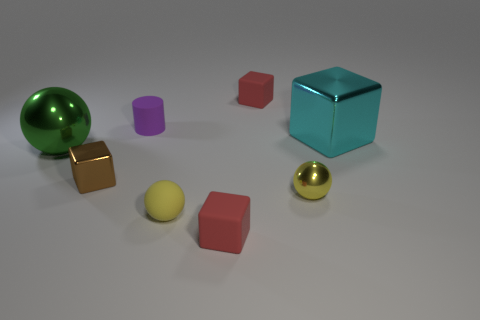Subtract all small yellow shiny balls. How many balls are left? 2 Add 2 shiny balls. How many objects exist? 10 Subtract all green balls. How many balls are left? 2 Subtract all green cylinders. How many red cubes are left? 2 Subtract all cylinders. How many objects are left? 7 Subtract 1 balls. How many balls are left? 2 Add 8 small blue cylinders. How many small blue cylinders exist? 8 Subtract 1 green spheres. How many objects are left? 7 Subtract all purple spheres. Subtract all brown cylinders. How many spheres are left? 3 Subtract all cyan blocks. Subtract all big green metal spheres. How many objects are left? 6 